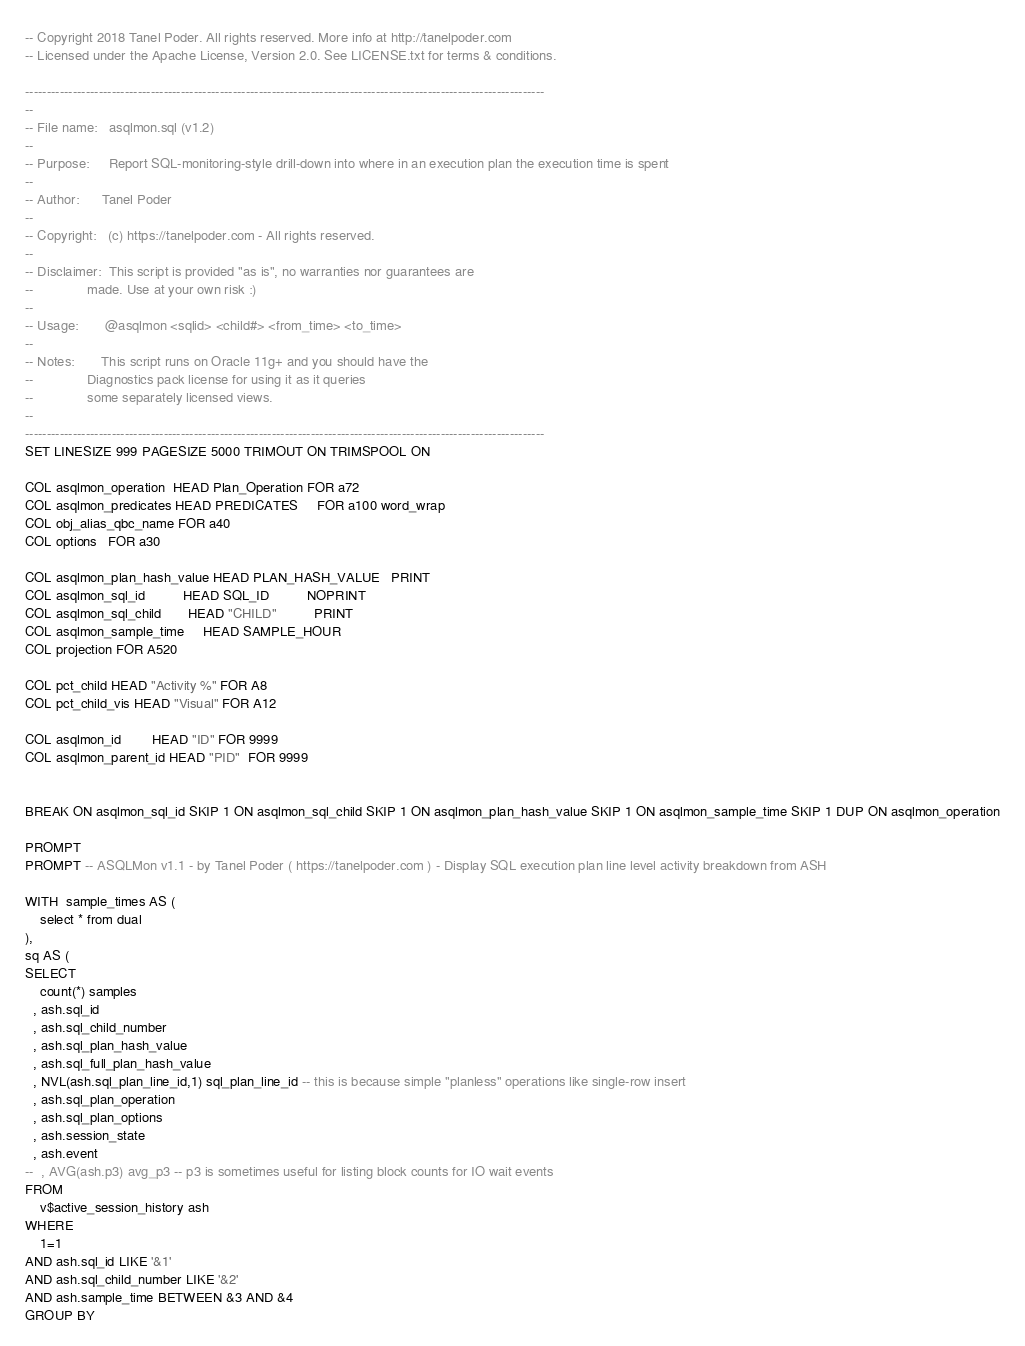<code> <loc_0><loc_0><loc_500><loc_500><_SQL_>-- Copyright 2018 Tanel Poder. All rights reserved. More info at http://tanelpoder.com
-- Licensed under the Apache License, Version 2.0. See LICENSE.txt for terms & conditions.

------------------------------------------------------------------------------------------------------------------------
--
-- File name:   asqlmon.sql (v1.2)
--
-- Purpose:     Report SQL-monitoring-style drill-down into where in an execution plan the execution time is spent
--
-- Author:      Tanel Poder
--
-- Copyright:   (c) https://tanelpoder.com - All rights reserved.
--
-- Disclaimer:  This script is provided "as is", no warranties nor guarantees are
--              made. Use at your own risk :)
--              
-- Usage:       @asqlmon <sqlid> <child#> <from_time> <to_time>
--
-- Notes:       This script runs on Oracle 11g+ and you should have the
--              Diagnostics pack license for using it as it queries
--              some separately licensed views.
--
------------------------------------------------------------------------------------------------------------------------
SET LINESIZE 999 PAGESIZE 5000 TRIMOUT ON TRIMSPOOL ON 

COL asqlmon_operation  HEAD Plan_Operation FOR a72
COL asqlmon_predicates HEAD PREDICATES     FOR a100 word_wrap
COL obj_alias_qbc_name FOR a40
COL options   FOR a30

COL asqlmon_plan_hash_value HEAD PLAN_HASH_VALUE   PRINT
COL asqlmon_sql_id          HEAD SQL_ID          NOPRINT
COL asqlmon_sql_child       HEAD "CHILD"          PRINT
COL asqlmon_sample_time     HEAD SAMPLE_HOUR
COL projection FOR A520

COL pct_child HEAD "Activity %" FOR A8
COL pct_child_vis HEAD "Visual" FOR A12

COL asqlmon_id        HEAD "ID" FOR 9999
COL asqlmon_parent_id HEAD "PID"  FOR 9999


BREAK ON asqlmon_sql_id SKIP 1 ON asqlmon_sql_child SKIP 1 ON asqlmon_plan_hash_value SKIP 1 ON asqlmon_sample_time SKIP 1 DUP ON asqlmon_operation

PROMPT
PROMPT -- ASQLMon v1.1 - by Tanel Poder ( https://tanelpoder.com ) - Display SQL execution plan line level activity breakdown from ASH

WITH  sample_times AS (
    select * from dual
), 
sq AS (
SELECT
    count(*) samples
  , ash.sql_id
  , ash.sql_child_number
  , ash.sql_plan_hash_value
  , ash.sql_full_plan_hash_value
  , NVL(ash.sql_plan_line_id,1) sql_plan_line_id -- this is because simple "planless" operations like single-row insert
  , ash.sql_plan_operation
  , ash.sql_plan_options
  , ash.session_state
  , ash.event
--  , AVG(ash.p3) avg_p3 -- p3 is sometimes useful for listing block counts for IO wait events
FROM
    v$active_session_history ash
WHERE
    1=1
AND ash.sql_id LIKE '&1'
AND ash.sql_child_number LIKE '&2'
AND ash.sample_time BETWEEN &3 AND &4
GROUP BY</code> 